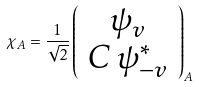<formula> <loc_0><loc_0><loc_500><loc_500>\chi _ { A } = \frac { 1 } { \sqrt { 2 } } \left ( \begin{array} { c } \psi _ { v } \\ C \, \psi ^ { * } _ { - v } \end{array} \right ) _ { A }</formula> 